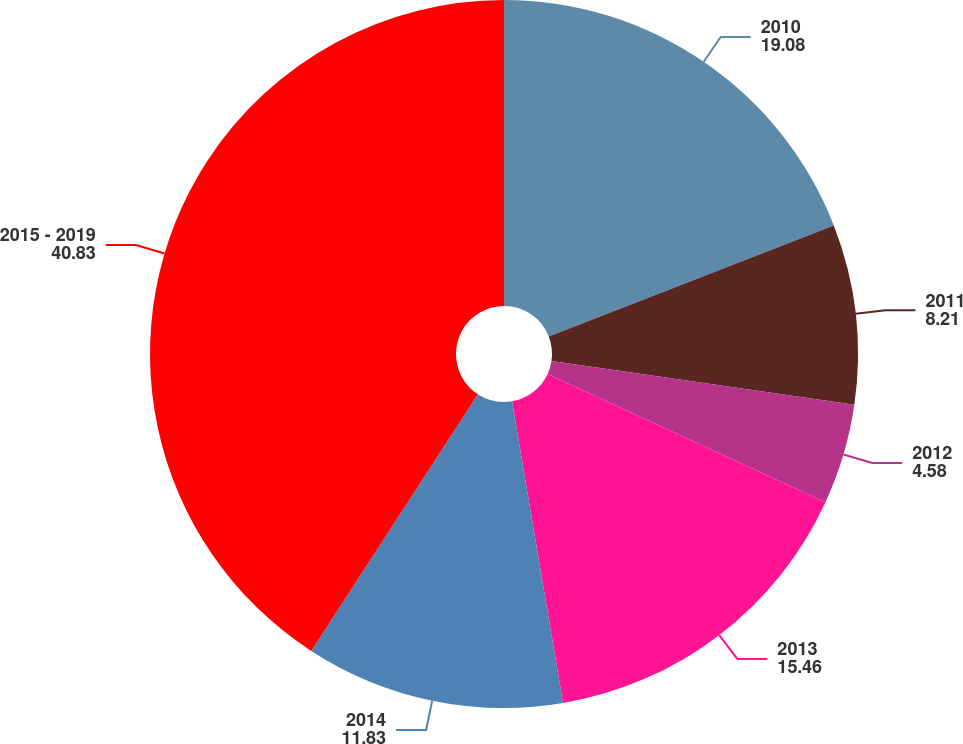Convert chart to OTSL. <chart><loc_0><loc_0><loc_500><loc_500><pie_chart><fcel>2010<fcel>2011<fcel>2012<fcel>2013<fcel>2014<fcel>2015 - 2019<nl><fcel>19.08%<fcel>8.21%<fcel>4.58%<fcel>15.46%<fcel>11.83%<fcel>40.83%<nl></chart> 